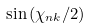<formula> <loc_0><loc_0><loc_500><loc_500>\sin { ( \chi _ { n k } / 2 ) }</formula> 